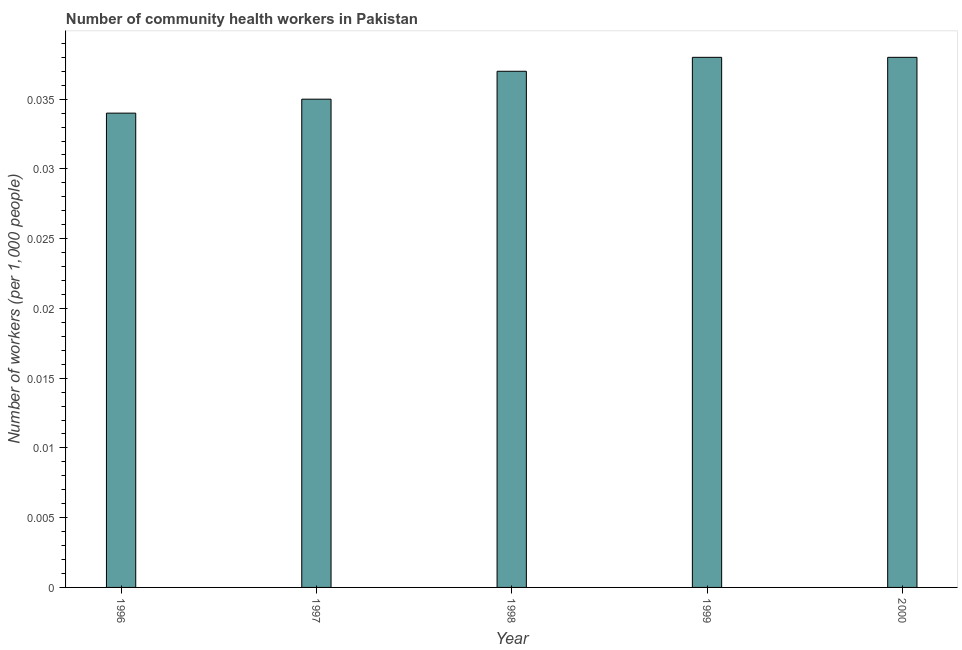Does the graph contain any zero values?
Provide a short and direct response. No. Does the graph contain grids?
Your response must be concise. No. What is the title of the graph?
Ensure brevity in your answer.  Number of community health workers in Pakistan. What is the label or title of the Y-axis?
Your answer should be compact. Number of workers (per 1,0 people). What is the number of community health workers in 2000?
Give a very brief answer. 0.04. Across all years, what is the maximum number of community health workers?
Provide a succinct answer. 0.04. Across all years, what is the minimum number of community health workers?
Your answer should be compact. 0.03. In which year was the number of community health workers maximum?
Your response must be concise. 1999. In which year was the number of community health workers minimum?
Your answer should be compact. 1996. What is the sum of the number of community health workers?
Keep it short and to the point. 0.18. What is the difference between the number of community health workers in 1996 and 1999?
Provide a succinct answer. -0. What is the average number of community health workers per year?
Your answer should be very brief. 0.04. What is the median number of community health workers?
Your answer should be compact. 0.04. In how many years, is the number of community health workers greater than 0.003 ?
Keep it short and to the point. 5. What is the ratio of the number of community health workers in 1997 to that in 1999?
Provide a succinct answer. 0.92. Is the number of community health workers in 1996 less than that in 1998?
Your answer should be compact. Yes. Are all the bars in the graph horizontal?
Make the answer very short. No. How many years are there in the graph?
Your answer should be very brief. 5. What is the difference between two consecutive major ticks on the Y-axis?
Ensure brevity in your answer.  0.01. What is the Number of workers (per 1,000 people) in 1996?
Your answer should be compact. 0.03. What is the Number of workers (per 1,000 people) of 1997?
Ensure brevity in your answer.  0.04. What is the Number of workers (per 1,000 people) in 1998?
Offer a very short reply. 0.04. What is the Number of workers (per 1,000 people) in 1999?
Ensure brevity in your answer.  0.04. What is the Number of workers (per 1,000 people) in 2000?
Your answer should be very brief. 0.04. What is the difference between the Number of workers (per 1,000 people) in 1996 and 1997?
Offer a very short reply. -0. What is the difference between the Number of workers (per 1,000 people) in 1996 and 1998?
Ensure brevity in your answer.  -0. What is the difference between the Number of workers (per 1,000 people) in 1996 and 1999?
Your answer should be compact. -0. What is the difference between the Number of workers (per 1,000 people) in 1996 and 2000?
Offer a terse response. -0. What is the difference between the Number of workers (per 1,000 people) in 1997 and 1998?
Your answer should be very brief. -0. What is the difference between the Number of workers (per 1,000 people) in 1997 and 1999?
Your answer should be very brief. -0. What is the difference between the Number of workers (per 1,000 people) in 1997 and 2000?
Offer a terse response. -0. What is the difference between the Number of workers (per 1,000 people) in 1998 and 1999?
Your response must be concise. -0. What is the difference between the Number of workers (per 1,000 people) in 1998 and 2000?
Your answer should be very brief. -0. What is the difference between the Number of workers (per 1,000 people) in 1999 and 2000?
Your answer should be compact. 0. What is the ratio of the Number of workers (per 1,000 people) in 1996 to that in 1998?
Keep it short and to the point. 0.92. What is the ratio of the Number of workers (per 1,000 people) in 1996 to that in 1999?
Provide a short and direct response. 0.9. What is the ratio of the Number of workers (per 1,000 people) in 1996 to that in 2000?
Give a very brief answer. 0.9. What is the ratio of the Number of workers (per 1,000 people) in 1997 to that in 1998?
Provide a succinct answer. 0.95. What is the ratio of the Number of workers (per 1,000 people) in 1997 to that in 1999?
Make the answer very short. 0.92. What is the ratio of the Number of workers (per 1,000 people) in 1997 to that in 2000?
Offer a very short reply. 0.92. What is the ratio of the Number of workers (per 1,000 people) in 1998 to that in 1999?
Ensure brevity in your answer.  0.97. What is the ratio of the Number of workers (per 1,000 people) in 1998 to that in 2000?
Provide a short and direct response. 0.97. 